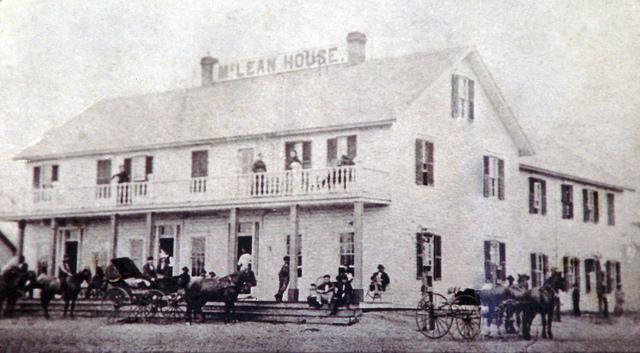How many horses are there in the photo?
Give a very brief answer. 4. 